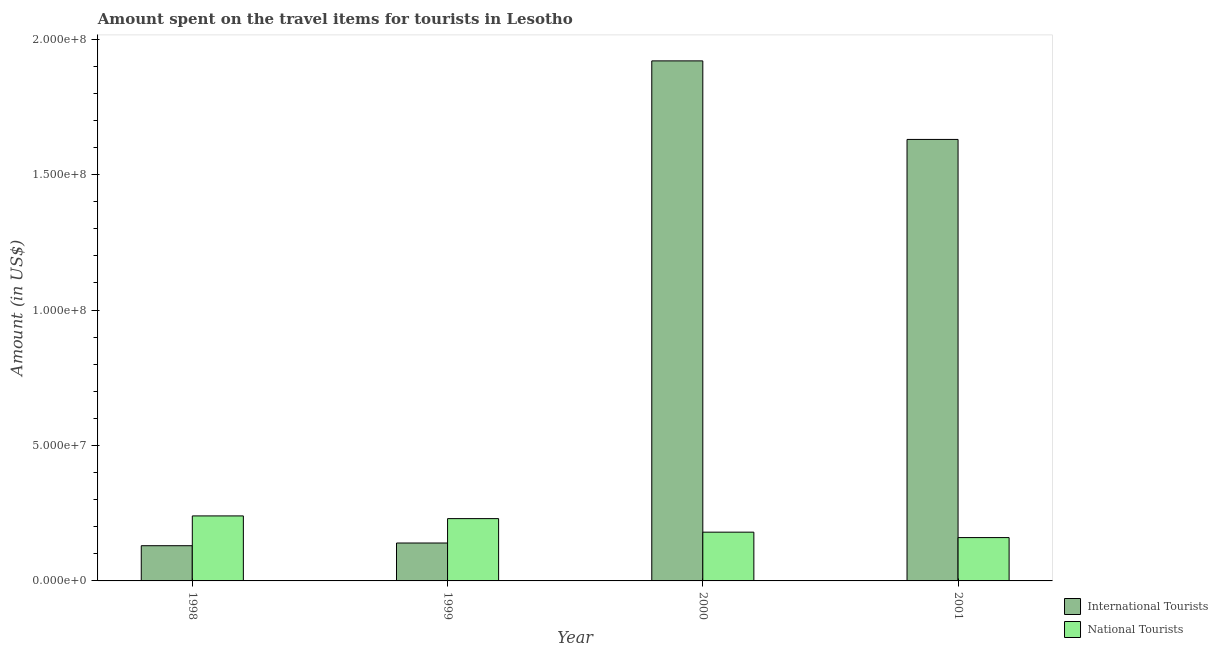How many groups of bars are there?
Your answer should be compact. 4. Are the number of bars per tick equal to the number of legend labels?
Your answer should be very brief. Yes. Are the number of bars on each tick of the X-axis equal?
Ensure brevity in your answer.  Yes. How many bars are there on the 3rd tick from the right?
Give a very brief answer. 2. What is the label of the 4th group of bars from the left?
Make the answer very short. 2001. What is the amount spent on travel items of national tourists in 1999?
Your answer should be compact. 2.30e+07. Across all years, what is the maximum amount spent on travel items of national tourists?
Provide a succinct answer. 2.40e+07. Across all years, what is the minimum amount spent on travel items of national tourists?
Your response must be concise. 1.60e+07. In which year was the amount spent on travel items of national tourists minimum?
Make the answer very short. 2001. What is the total amount spent on travel items of international tourists in the graph?
Keep it short and to the point. 3.82e+08. What is the difference between the amount spent on travel items of national tourists in 1999 and that in 2000?
Offer a terse response. 5.00e+06. What is the difference between the amount spent on travel items of national tourists in 1999 and the amount spent on travel items of international tourists in 1998?
Give a very brief answer. -1.00e+06. What is the average amount spent on travel items of national tourists per year?
Provide a succinct answer. 2.02e+07. What is the ratio of the amount spent on travel items of national tourists in 1998 to that in 2001?
Offer a very short reply. 1.5. Is the amount spent on travel items of international tourists in 1998 less than that in 1999?
Make the answer very short. Yes. Is the difference between the amount spent on travel items of international tourists in 2000 and 2001 greater than the difference between the amount spent on travel items of national tourists in 2000 and 2001?
Your answer should be compact. No. What is the difference between the highest and the second highest amount spent on travel items of international tourists?
Keep it short and to the point. 2.90e+07. What is the difference between the highest and the lowest amount spent on travel items of national tourists?
Provide a short and direct response. 8.00e+06. What does the 1st bar from the left in 1998 represents?
Your response must be concise. International Tourists. What does the 2nd bar from the right in 1998 represents?
Provide a short and direct response. International Tourists. How many bars are there?
Make the answer very short. 8. What is the difference between two consecutive major ticks on the Y-axis?
Your response must be concise. 5.00e+07. Does the graph contain any zero values?
Your answer should be very brief. No. Does the graph contain grids?
Offer a terse response. No. How are the legend labels stacked?
Provide a short and direct response. Vertical. What is the title of the graph?
Your answer should be very brief. Amount spent on the travel items for tourists in Lesotho. What is the label or title of the Y-axis?
Provide a short and direct response. Amount (in US$). What is the Amount (in US$) in International Tourists in 1998?
Provide a succinct answer. 1.30e+07. What is the Amount (in US$) in National Tourists in 1998?
Give a very brief answer. 2.40e+07. What is the Amount (in US$) of International Tourists in 1999?
Provide a short and direct response. 1.40e+07. What is the Amount (in US$) of National Tourists in 1999?
Offer a very short reply. 2.30e+07. What is the Amount (in US$) of International Tourists in 2000?
Offer a very short reply. 1.92e+08. What is the Amount (in US$) in National Tourists in 2000?
Keep it short and to the point. 1.80e+07. What is the Amount (in US$) in International Tourists in 2001?
Ensure brevity in your answer.  1.63e+08. What is the Amount (in US$) of National Tourists in 2001?
Your answer should be compact. 1.60e+07. Across all years, what is the maximum Amount (in US$) of International Tourists?
Keep it short and to the point. 1.92e+08. Across all years, what is the maximum Amount (in US$) in National Tourists?
Keep it short and to the point. 2.40e+07. Across all years, what is the minimum Amount (in US$) of International Tourists?
Provide a succinct answer. 1.30e+07. Across all years, what is the minimum Amount (in US$) of National Tourists?
Your answer should be very brief. 1.60e+07. What is the total Amount (in US$) in International Tourists in the graph?
Your answer should be very brief. 3.82e+08. What is the total Amount (in US$) in National Tourists in the graph?
Ensure brevity in your answer.  8.10e+07. What is the difference between the Amount (in US$) in International Tourists in 1998 and that in 2000?
Make the answer very short. -1.79e+08. What is the difference between the Amount (in US$) in International Tourists in 1998 and that in 2001?
Provide a succinct answer. -1.50e+08. What is the difference between the Amount (in US$) of International Tourists in 1999 and that in 2000?
Provide a succinct answer. -1.78e+08. What is the difference between the Amount (in US$) of International Tourists in 1999 and that in 2001?
Keep it short and to the point. -1.49e+08. What is the difference between the Amount (in US$) of International Tourists in 2000 and that in 2001?
Keep it short and to the point. 2.90e+07. What is the difference between the Amount (in US$) of National Tourists in 2000 and that in 2001?
Keep it short and to the point. 2.00e+06. What is the difference between the Amount (in US$) in International Tourists in 1998 and the Amount (in US$) in National Tourists in 1999?
Provide a succinct answer. -1.00e+07. What is the difference between the Amount (in US$) in International Tourists in 1998 and the Amount (in US$) in National Tourists in 2000?
Ensure brevity in your answer.  -5.00e+06. What is the difference between the Amount (in US$) of International Tourists in 1998 and the Amount (in US$) of National Tourists in 2001?
Provide a succinct answer. -3.00e+06. What is the difference between the Amount (in US$) of International Tourists in 1999 and the Amount (in US$) of National Tourists in 2000?
Offer a very short reply. -4.00e+06. What is the difference between the Amount (in US$) of International Tourists in 1999 and the Amount (in US$) of National Tourists in 2001?
Provide a short and direct response. -2.00e+06. What is the difference between the Amount (in US$) in International Tourists in 2000 and the Amount (in US$) in National Tourists in 2001?
Keep it short and to the point. 1.76e+08. What is the average Amount (in US$) of International Tourists per year?
Make the answer very short. 9.55e+07. What is the average Amount (in US$) of National Tourists per year?
Your response must be concise. 2.02e+07. In the year 1998, what is the difference between the Amount (in US$) of International Tourists and Amount (in US$) of National Tourists?
Offer a terse response. -1.10e+07. In the year 1999, what is the difference between the Amount (in US$) in International Tourists and Amount (in US$) in National Tourists?
Your answer should be compact. -9.00e+06. In the year 2000, what is the difference between the Amount (in US$) of International Tourists and Amount (in US$) of National Tourists?
Offer a very short reply. 1.74e+08. In the year 2001, what is the difference between the Amount (in US$) in International Tourists and Amount (in US$) in National Tourists?
Give a very brief answer. 1.47e+08. What is the ratio of the Amount (in US$) of National Tourists in 1998 to that in 1999?
Provide a succinct answer. 1.04. What is the ratio of the Amount (in US$) in International Tourists in 1998 to that in 2000?
Provide a succinct answer. 0.07. What is the ratio of the Amount (in US$) of National Tourists in 1998 to that in 2000?
Give a very brief answer. 1.33. What is the ratio of the Amount (in US$) of International Tourists in 1998 to that in 2001?
Your answer should be compact. 0.08. What is the ratio of the Amount (in US$) in National Tourists in 1998 to that in 2001?
Make the answer very short. 1.5. What is the ratio of the Amount (in US$) of International Tourists in 1999 to that in 2000?
Provide a succinct answer. 0.07. What is the ratio of the Amount (in US$) of National Tourists in 1999 to that in 2000?
Your response must be concise. 1.28. What is the ratio of the Amount (in US$) in International Tourists in 1999 to that in 2001?
Your answer should be very brief. 0.09. What is the ratio of the Amount (in US$) in National Tourists in 1999 to that in 2001?
Your answer should be compact. 1.44. What is the ratio of the Amount (in US$) of International Tourists in 2000 to that in 2001?
Offer a terse response. 1.18. What is the ratio of the Amount (in US$) in National Tourists in 2000 to that in 2001?
Provide a short and direct response. 1.12. What is the difference between the highest and the second highest Amount (in US$) of International Tourists?
Your answer should be compact. 2.90e+07. What is the difference between the highest and the lowest Amount (in US$) of International Tourists?
Provide a short and direct response. 1.79e+08. 